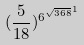<formula> <loc_0><loc_0><loc_500><loc_500>( \frac { 5 } { 1 8 } ) ^ { { 6 ^ { \sqrt { 3 6 8 } } } ^ { 1 } }</formula> 